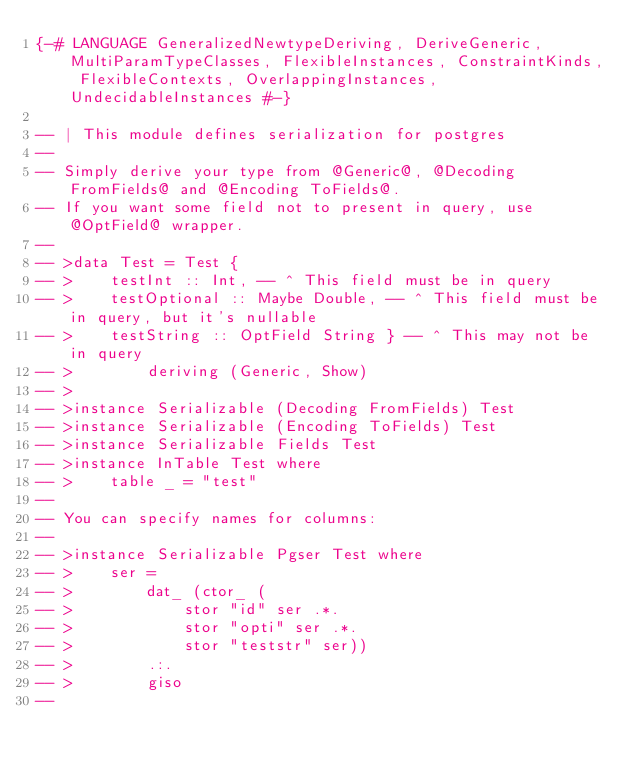Convert code to text. <code><loc_0><loc_0><loc_500><loc_500><_Haskell_>{-# LANGUAGE GeneralizedNewtypeDeriving, DeriveGeneric, MultiParamTypeClasses, FlexibleInstances, ConstraintKinds, FlexibleContexts, OverlappingInstances, UndecidableInstances #-}

-- | This module defines serialization for postgres
--
-- Simply derive your type from @Generic@, @Decoding FromFields@ and @Encoding ToFields@.
-- If you want some field not to present in query, use @OptField@ wrapper.
-- 
-- >data Test = Test {
-- >    testInt :: Int, -- ^ This field must be in query
-- >    testOptional :: Maybe Double, -- ^ This field must be in query, but it's nullable
-- >    testString :: OptField String } -- ^ This may not be in query
-- >        deriving (Generic, Show)
-- >
-- >instance Serializable (Decoding FromFields) Test
-- >instance Serializable (Encoding ToFields) Test
-- >instance Serializable Fields Test
-- >instance InTable Test where
-- >    table _ = "test"
-- 
-- You can specify names for columns:
--
-- >instance Serializable Pgser Test where
-- >    ser =
-- >        dat_ (ctor_ (
-- >            stor "id" ser .*.
-- >            stor "opti" ser .*.
-- >            stor "teststr" ser))
-- >        .:.
-- >        giso
--</code> 